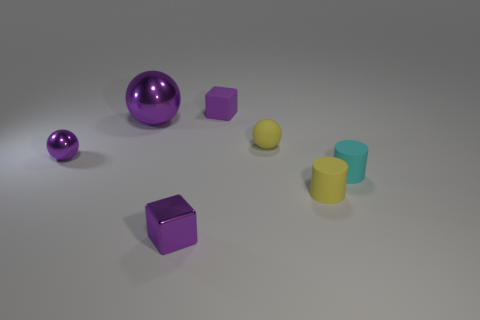Subtract all purple metallic balls. How many balls are left? 1 Subtract all cyan cylinders. How many cylinders are left? 1 Subtract 3 spheres. How many spheres are left? 0 Subtract all blue cubes. How many yellow spheres are left? 1 Add 2 objects. How many objects are left? 9 Add 2 tiny shiny objects. How many tiny shiny objects exist? 4 Add 1 large purple objects. How many objects exist? 8 Subtract 0 red spheres. How many objects are left? 7 Subtract all balls. How many objects are left? 4 Subtract all green blocks. Subtract all green cylinders. How many blocks are left? 2 